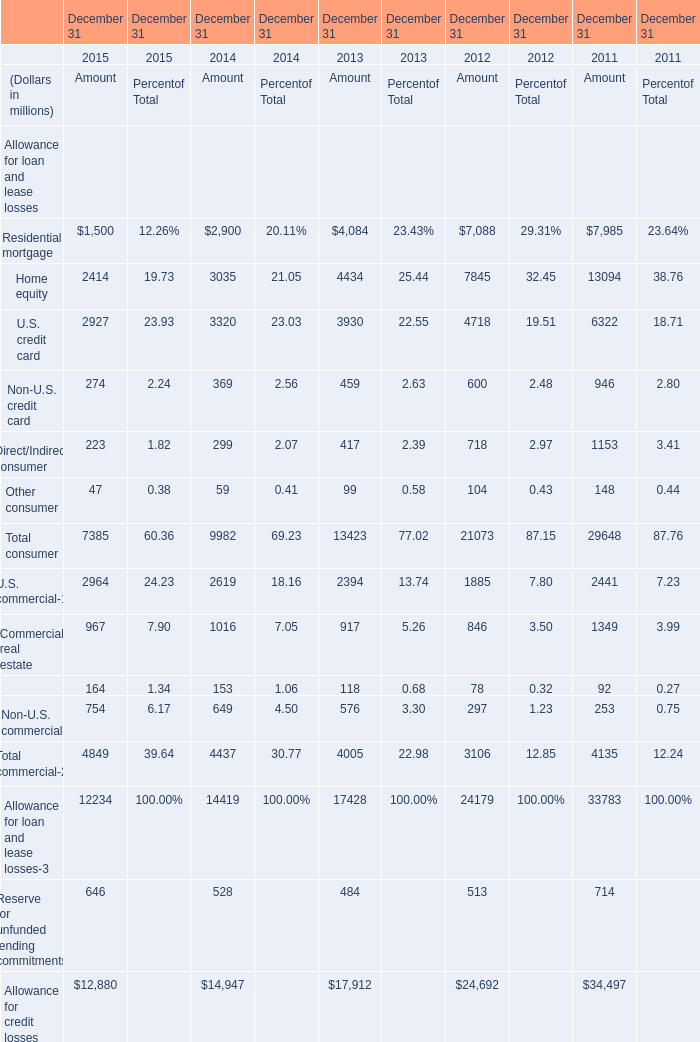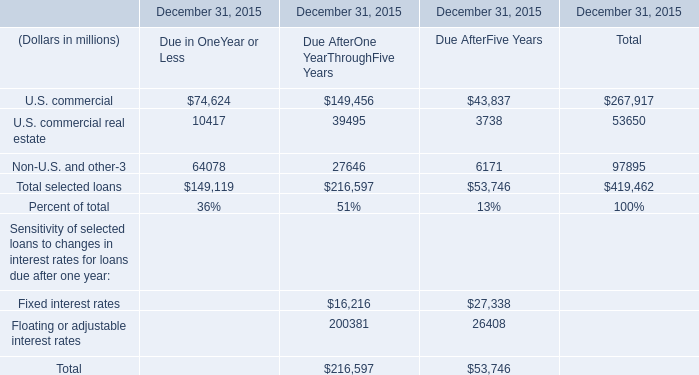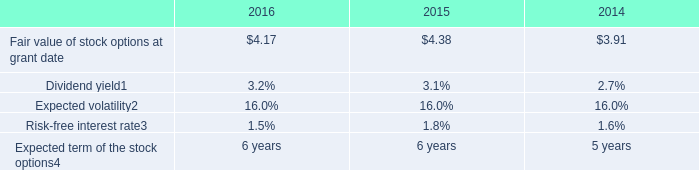What is the total amount of U.S. commercial of December 31, 2015 Due AfterFive Years, Commercial real estate of December 31 2014 Amount, and U.S. commercial of December 31 2015 Amount ? 
Computations: ((43837.0 + 1016.0) + 2964.0)
Answer: 47817.0. 